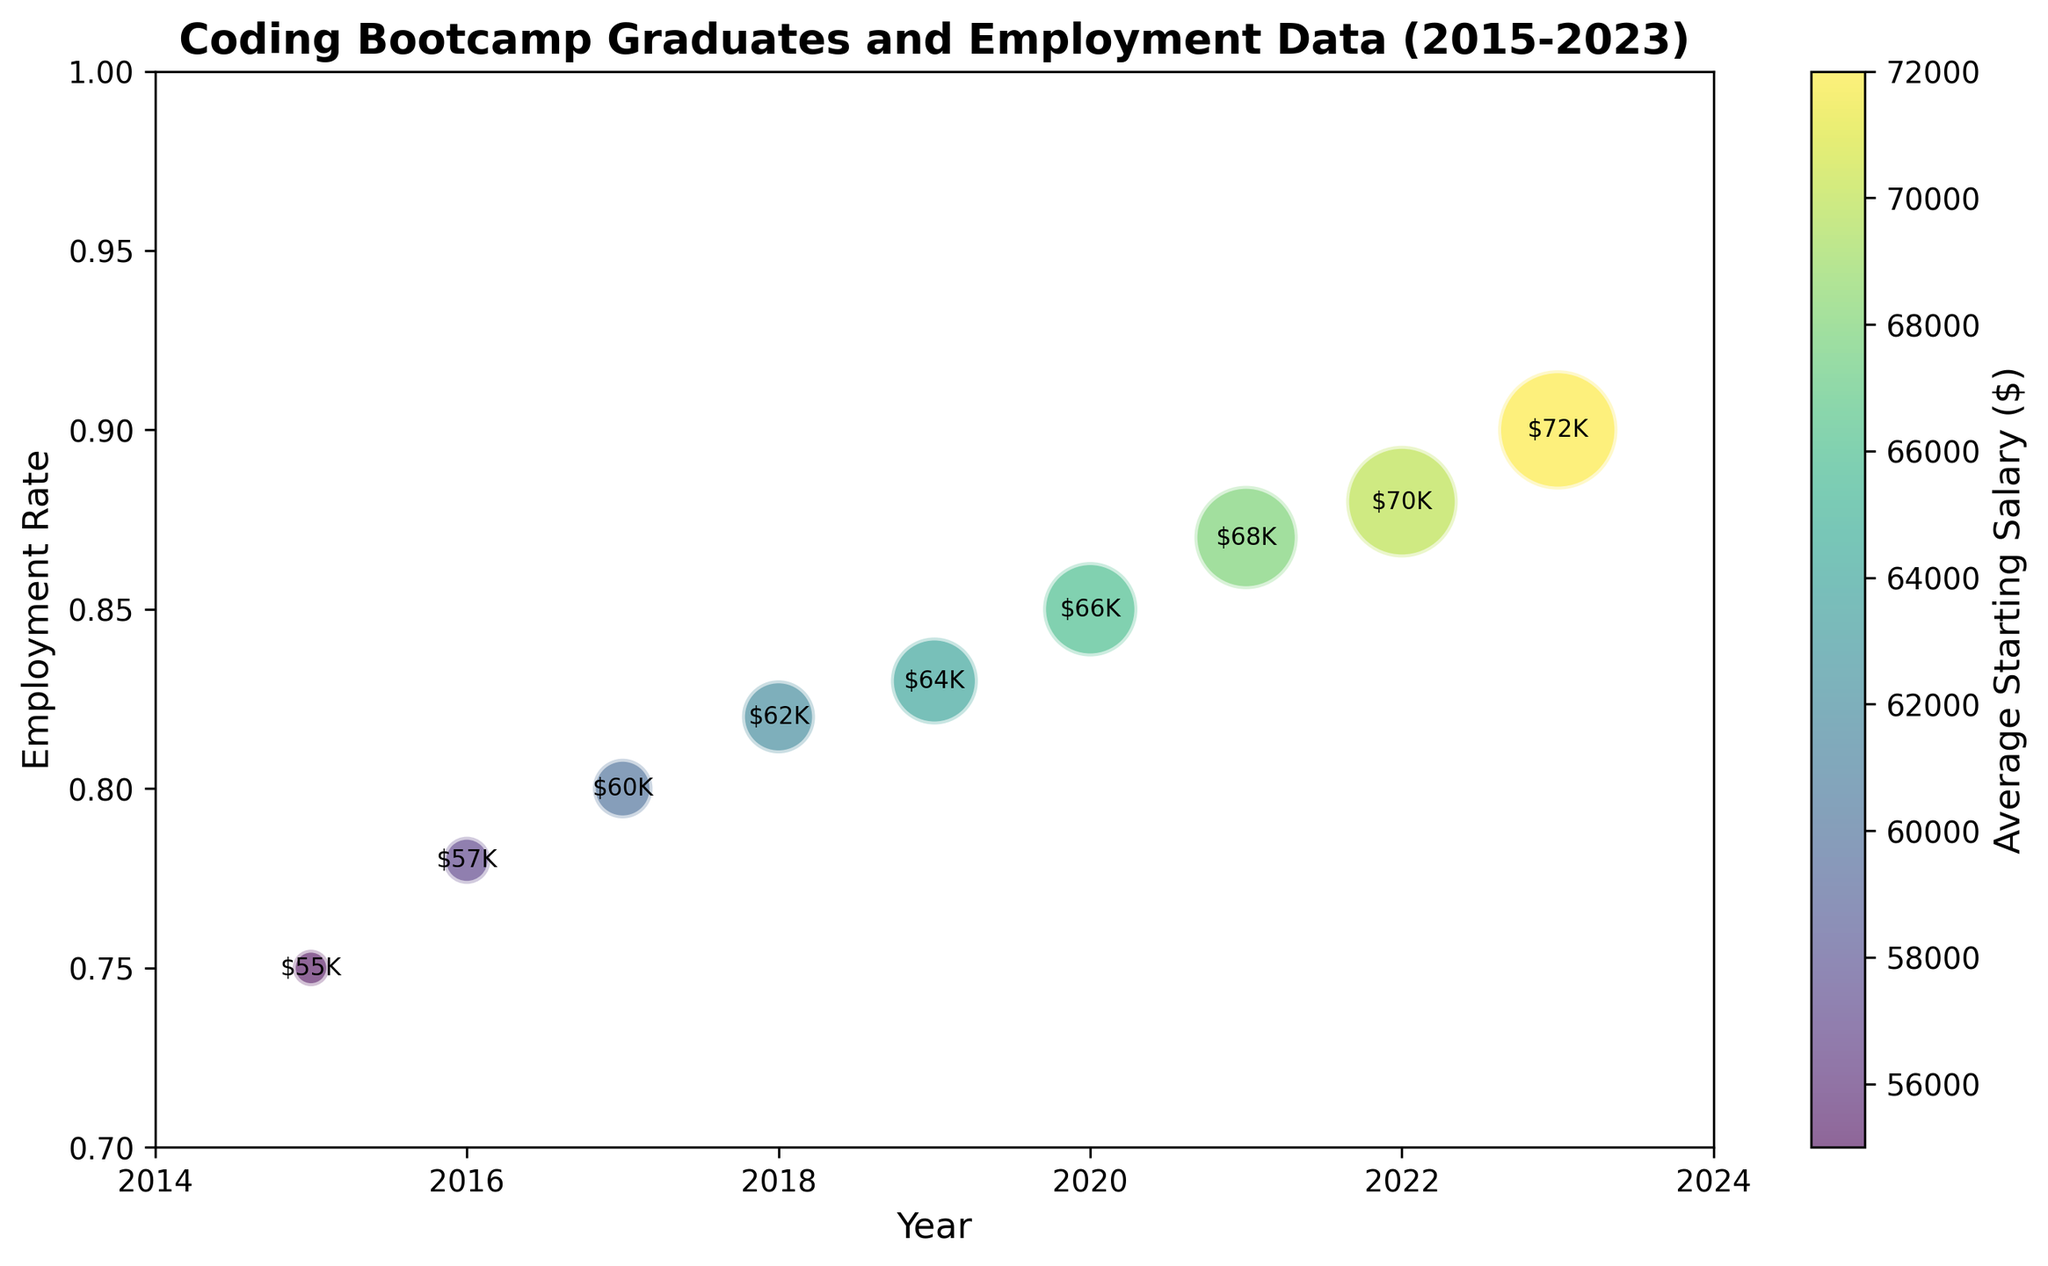How has the employment rate changed from 2015 to 2023? The plot shows the employment rate increases each year from 2015 to 2023. The rate starts at 0.75 in 2015 and rises to 0.90 in 2023.
Answer: It increased from 0.75 to 0.90 Between 2019 and 2022, in which year did the average starting salary increase the most? By comparing the starting salaries, 2019 to 2020 increases from $64K to $66K, 2020 to 2021 increases from $66K to $68K, and 2021 to 2022 increases from $68K to $70K. The most significant increase is from 2021 to 2022, which goes up by $2K.
Answer: 2021 to 2022 Which year had the highest number of coding bootcamp graduates? The year with the largest bubble represents the highest number of graduates. The largest bubble is in 2023.
Answer: 2023 What is the range of average starting salaries shown on the colorbar? The colorbar shows a gradient from the lowest to the highest average starting salaries. The starting salaries range from $55K to $72K.
Answer: $55K to $72K In which year was the employment rate exactly 0.80? By looking at the y-axis and finding the year where the employment rate aligns with 0.80, this occurs in 2017.
Answer: 2017 Which year shows the largest increase in employment rate compared to the previous year? By comparing the year-over-year increases in employment rate from the plot: 2015 to 2016 (0.03), 2016 to 2017 (0.02), 2017 to 2018 (0.02), 2018 to 2019 (0.01), 2019 to 2020 (0.02), 2020 to 2021 (0.02), 2021 to 2022 (0.01), 2022 to 2023 (0.02). The 2015 to 2016 increase of 0.03 is the largest.
Answer: 2015 to 2016 How many more graduates were there in 2020 compared to 2018? The number of graduates in 2020 is 10,000 and in 2018 is 6,000. The difference is 10,000 - 6,000 = 4,000.
Answer: 4,000 Is there a positive correlation between the employment rate and the average starting salary? Both the employment rate and average starting salary increase through the years as shown by the upward trend in the plot and the color gradient.
Answer: Yes What is the main trend visible in the number of coding bootcamp graduates over the years? The size of the bubbles representing graduates increases each year, indicating a steady rise in the number of graduates from 2015 to 2023.
Answer: Increasing trend 